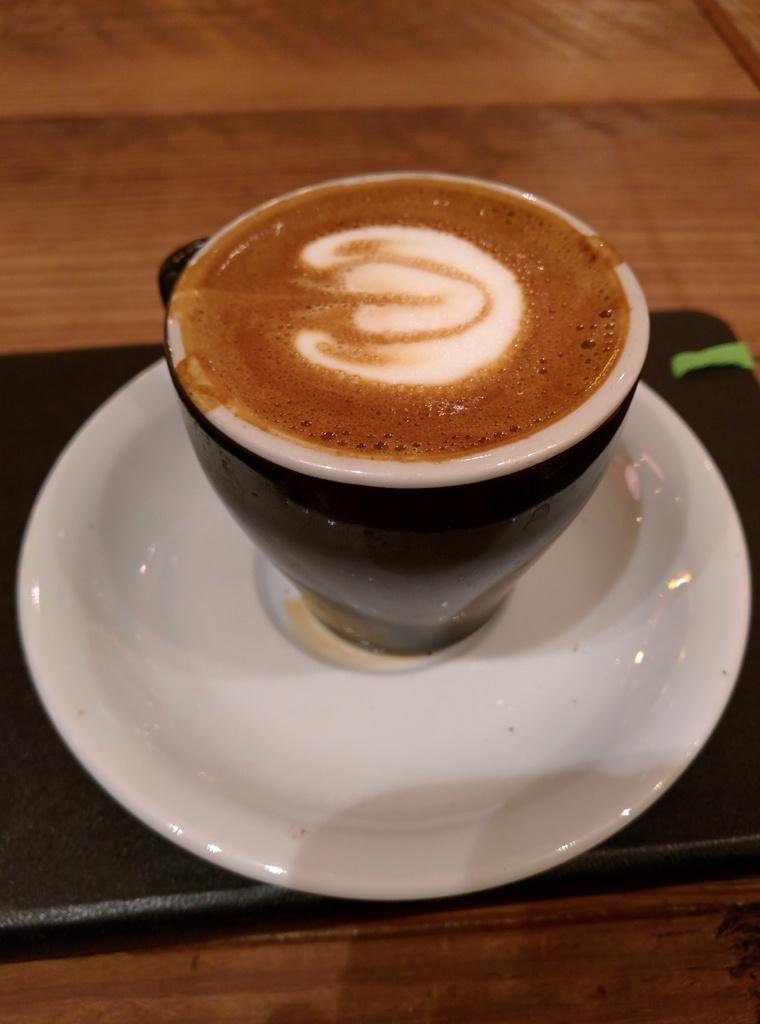What is in the cup that is visible in the image? There is a cup of coffee in the image. What is the cup of coffee resting on? The cup of coffee is on a saucer. Where is the saucer located in the image? The saucer is in the center of the image. Is there anything else supporting the saucer in the image? Yes, there appears to be a tray under the saucer. What type of lettuce is being used as a tablecloth in the image? There is no lettuce present in the image, nor is it being used as a tablecloth. 